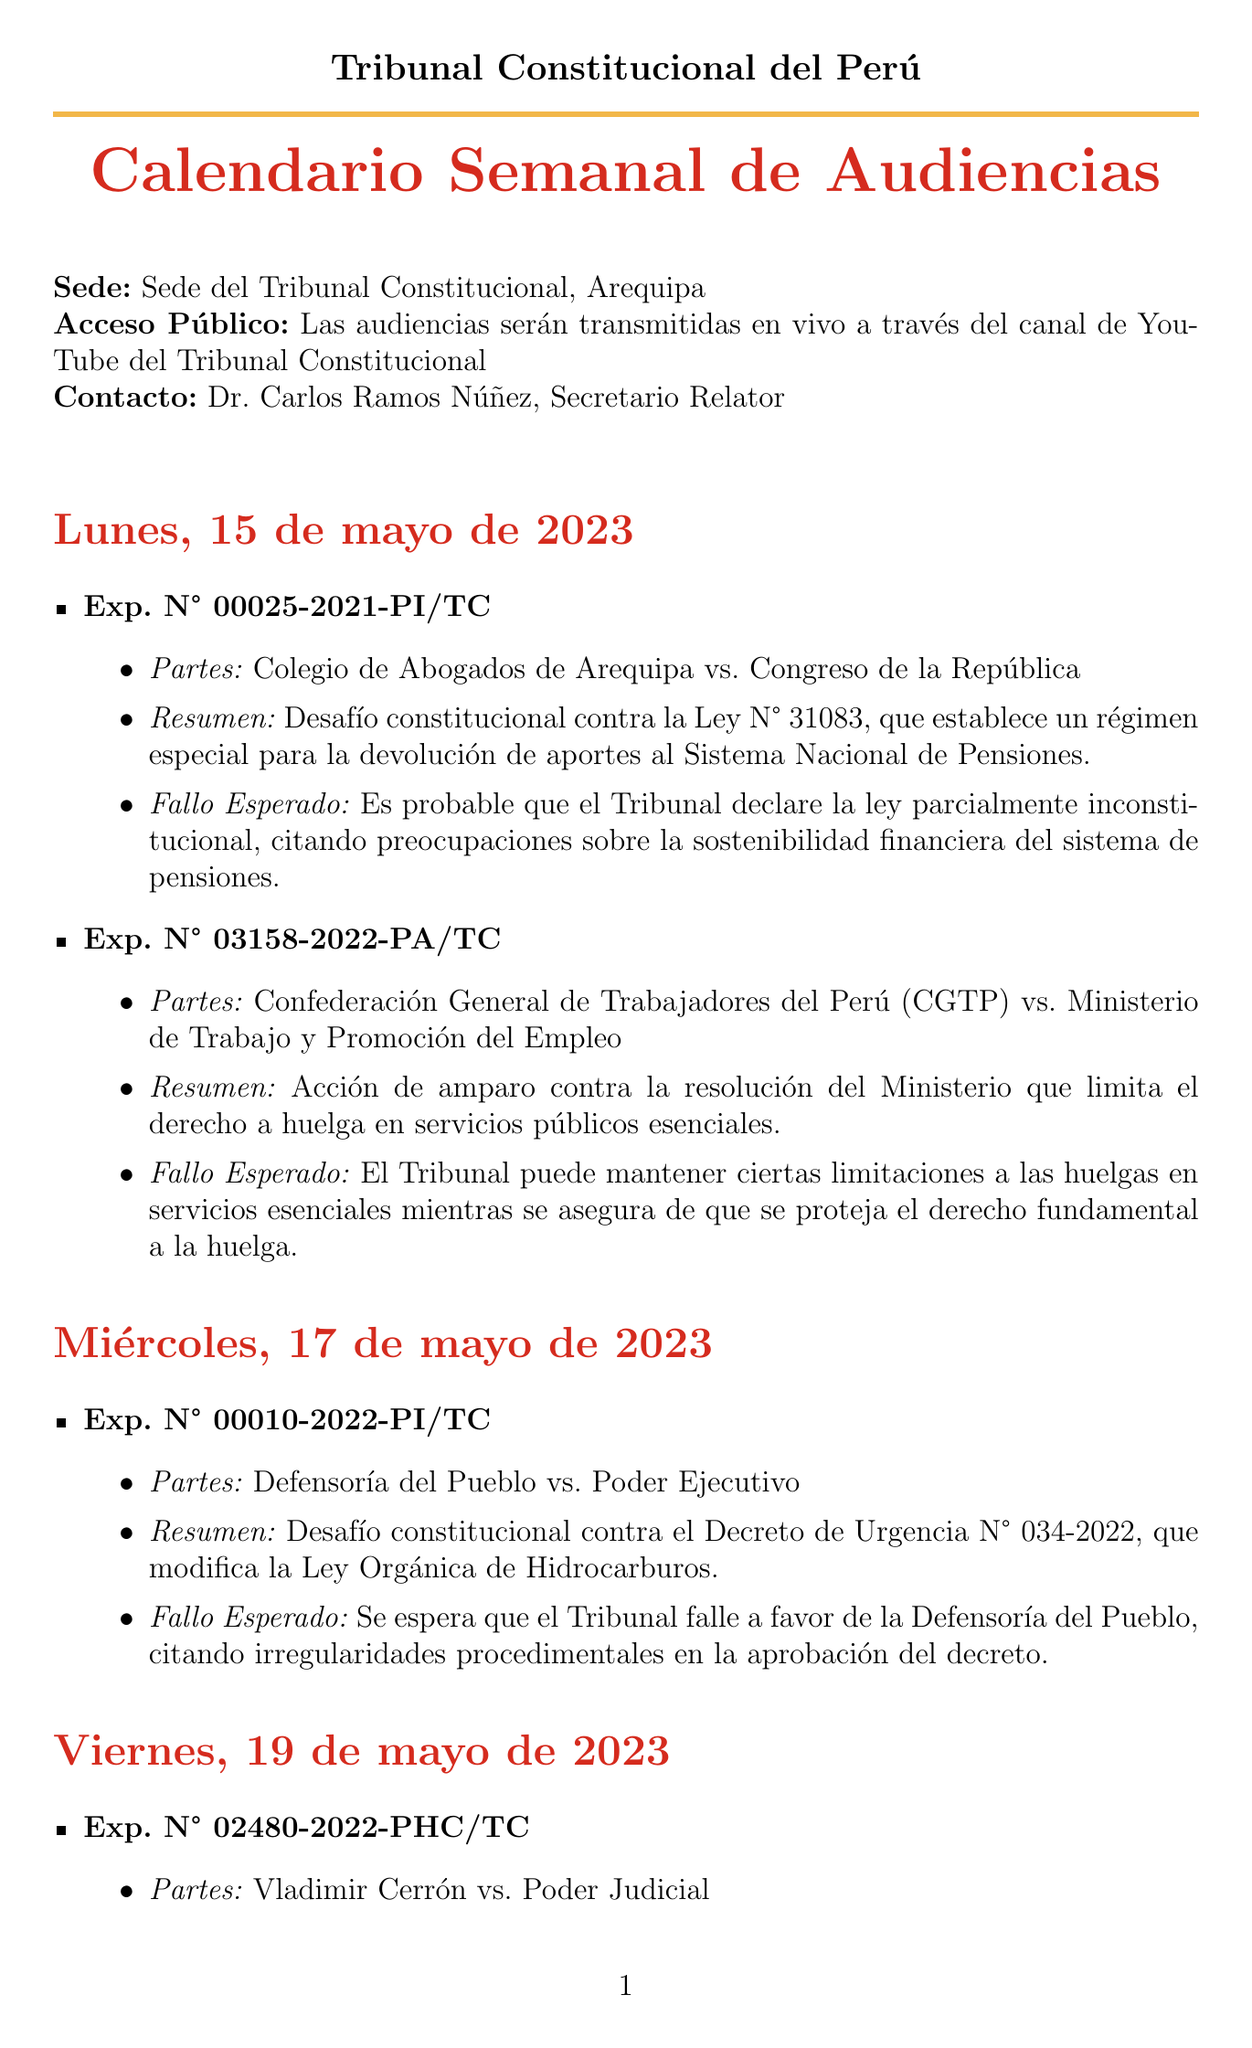What is the date of the first hearing? The first hearing is scheduled for May 15, 2023, according to the document.
Answer: May 15, 2023 Who are the parties involved in the case Exp. N° 00025-2021-PI/TC? The document lists the parties involved in this case as Colegio de Abogados de Arequipa and Congreso de la República.
Answer: Colegio de Abogados de Arequipa vs. Congreso de la República What is the expected ruling for the case Exp. N° 03158-2022-PA/TC? The expected ruling for this case is highlighted in the summary provided in the document.
Answer: The Court may uphold certain limitations on strikes in essential services while ensuring the core right to strike is protected On which date is the press conference scheduled? The document specifies that the press conference will take place on May 19, 2023.
Answer: May 19, 2023 What is the main issue in the case Exp. N° 00010-2022-PI/TC? The document describes the main issue as a constitutional challenge against Emergency Decree N° 034-2022.
Answer: A constitutional challenge against Emergency Decree N° 034-2022 What venue will the hearings take place? The document states that the hearings will take place at the Sede del Tribunal Constitucional in Arequipa.
Answer: Sede del Tribunal Constitucional, Arequipa What is the political climate mentioned in the document? The document highlights tensions between the Executive and Legislative branches due to recent emergency decrees as the political climate.
Answer: Tensión entre el Ejecutivo y el Legislativo por recientes decretos de urgencia How many cases are reviewed on May 19, 2023? The document indicates that there are two cases set for review on this date.
Answer: Two cases 